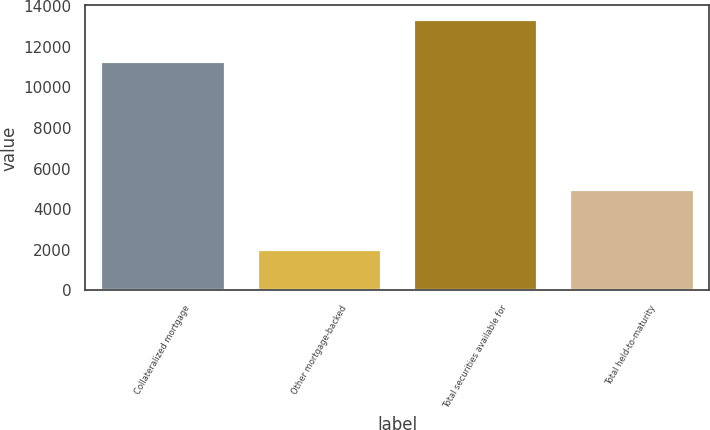<chart> <loc_0><loc_0><loc_500><loc_500><bar_chart><fcel>Collateralized mortgage<fcel>Other mortgage-backed<fcel>Total securities available for<fcel>Total held-to-maturity<nl><fcel>11270<fcel>2035<fcel>13360<fcel>4974<nl></chart> 